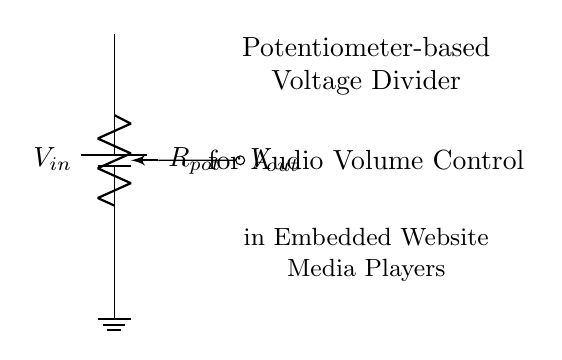What type of component is used for adjusting volume? The circuit includes a potentiometer, which is a variable resistor specifically designed to adjust levels, in this case, audio volume.
Answer: potentiometer What is the purpose of the potentiometer in this circuit? The potentiometer acts as a voltage divider, allowing the user to control the output voltage, which in turn adjusts the audio volume output.
Answer: voltage divider What is the input voltage denoted in the circuit? The input voltage is represented by V-in, which is the source voltage provided to the potentiometer for voltage division.
Answer: V-in Where does the output voltage connect in the circuit? The output voltage, referred to as V-out, is connected to the wiper of the potentiometer, which is where the adjusted voltage is taken from.
Answer: wiper How does the potentiometer affect the output voltage? By turning the potentiometer, the resistance changes, which alters the division of input voltage and thus provides a different output voltage depending on the position of the wiper.
Answer: alters output voltage What kind of signal is intended to be controlled by this circuit? The circuit is designed to control audio signals, allowing for volume adjustments in media players.
Answer: audio signal What is the significance of the ground connection in this circuit? The ground connection serves as a reference point for the circuit's voltage levels, ensuring a proper return path for current and stabilizing the circuit operation.
Answer: reference point 